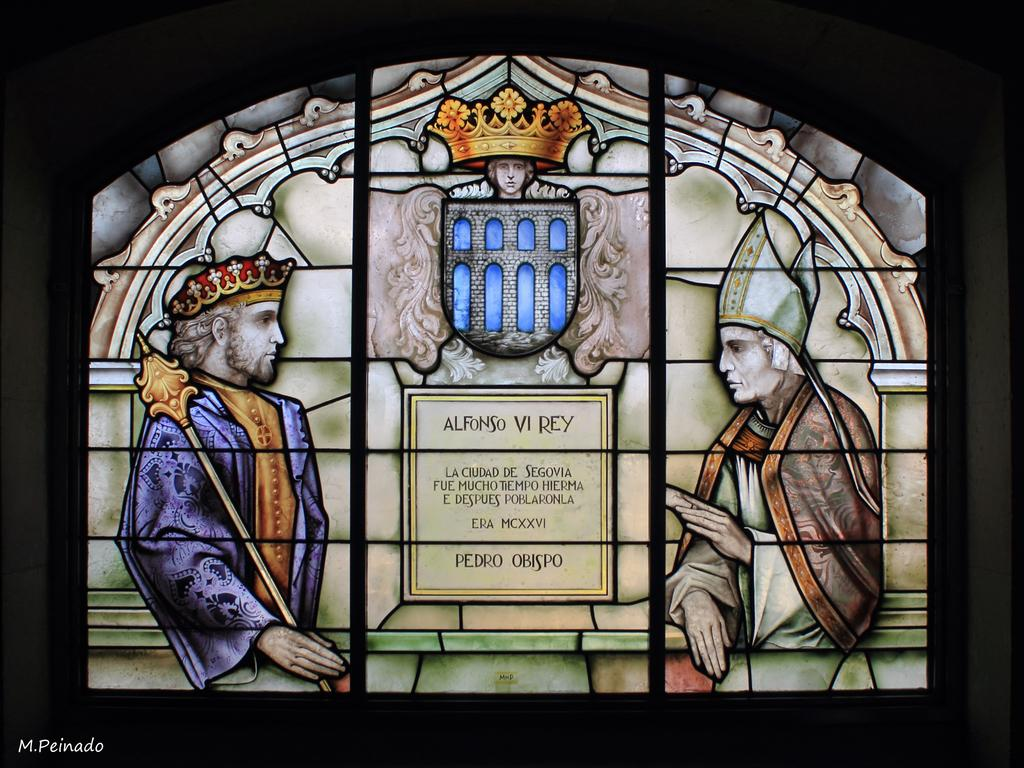Provide a one-sentence caption for the provided image. A stained glass window bears the name Pedro Obispo. 